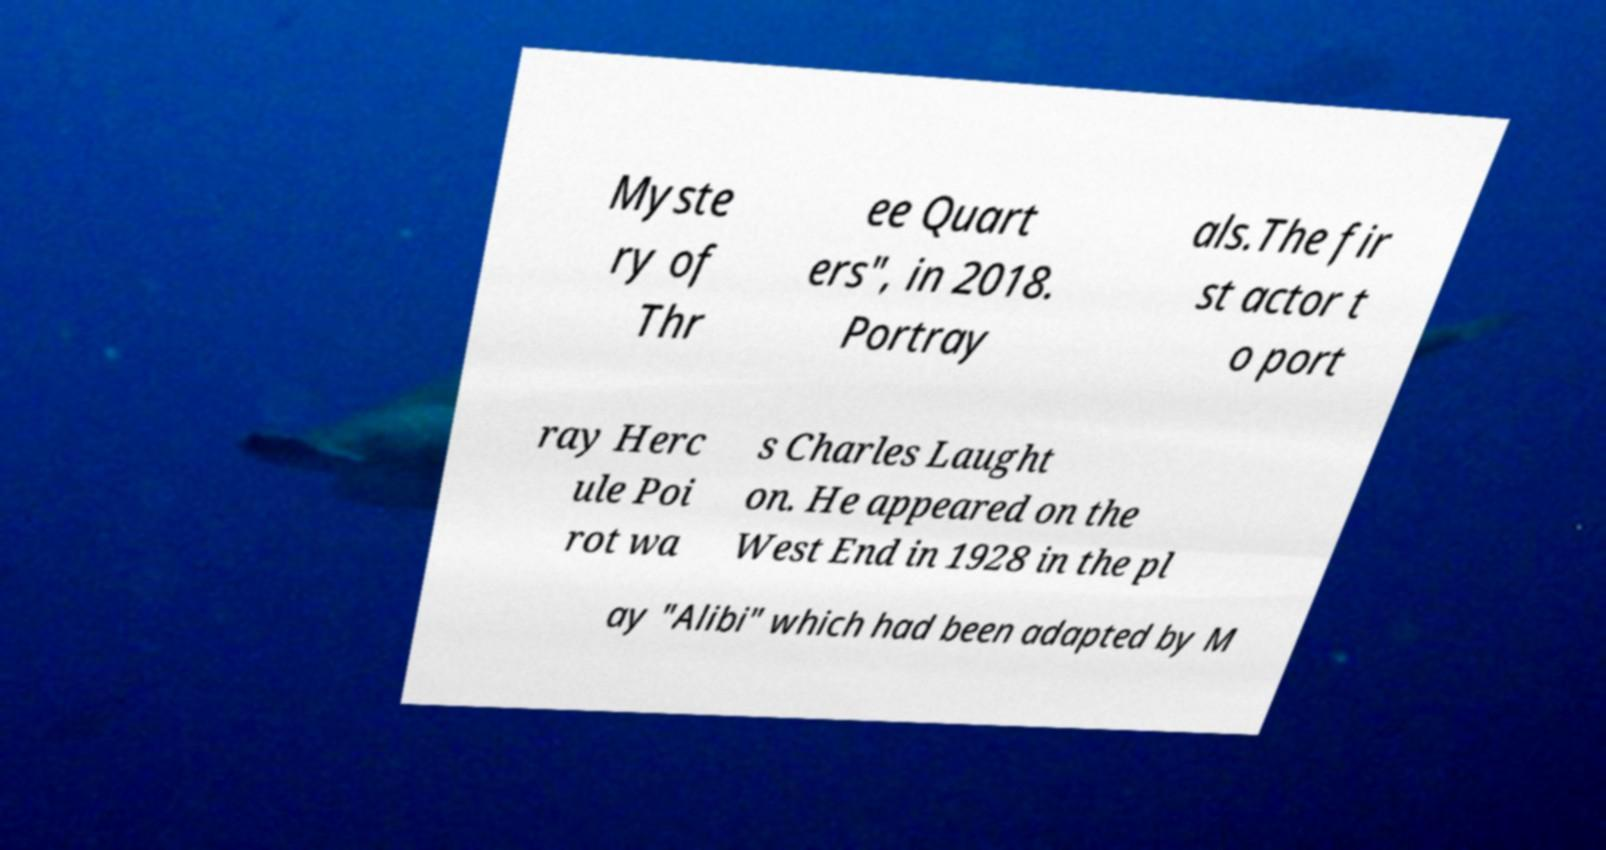Please identify and transcribe the text found in this image. Myste ry of Thr ee Quart ers", in 2018. Portray als.The fir st actor t o port ray Herc ule Poi rot wa s Charles Laught on. He appeared on the West End in 1928 in the pl ay "Alibi" which had been adapted by M 